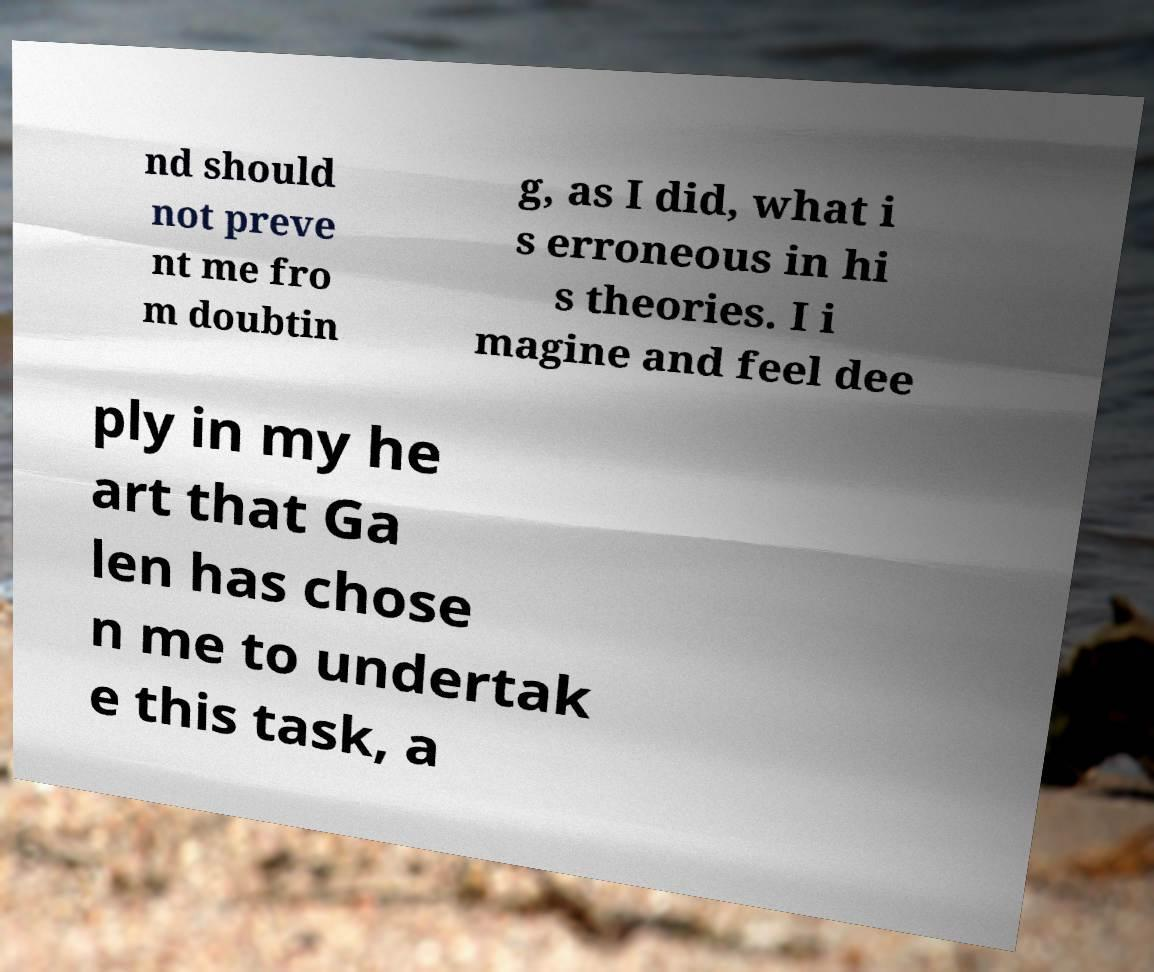Please read and relay the text visible in this image. What does it say? nd should not preve nt me fro m doubtin g, as I did, what i s erroneous in hi s theories. I i magine and feel dee ply in my he art that Ga len has chose n me to undertak e this task, a 